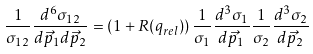<formula> <loc_0><loc_0><loc_500><loc_500>\frac { 1 } { \sigma _ { 1 2 } } \frac { d ^ { 6 } \sigma _ { 1 2 } } { d \vec { p } _ { 1 } d \vec { p } _ { 2 } } = \left ( 1 + R ( q _ { r e l } ) \right ) \frac { 1 } { \sigma _ { 1 } } \frac { d ^ { 3 } \sigma _ { 1 } } { d \vec { p } _ { 1 } } \frac { 1 } { \sigma _ { 2 } } \frac { d ^ { 3 } \sigma _ { 2 } } { d \vec { p } _ { 2 } }</formula> 